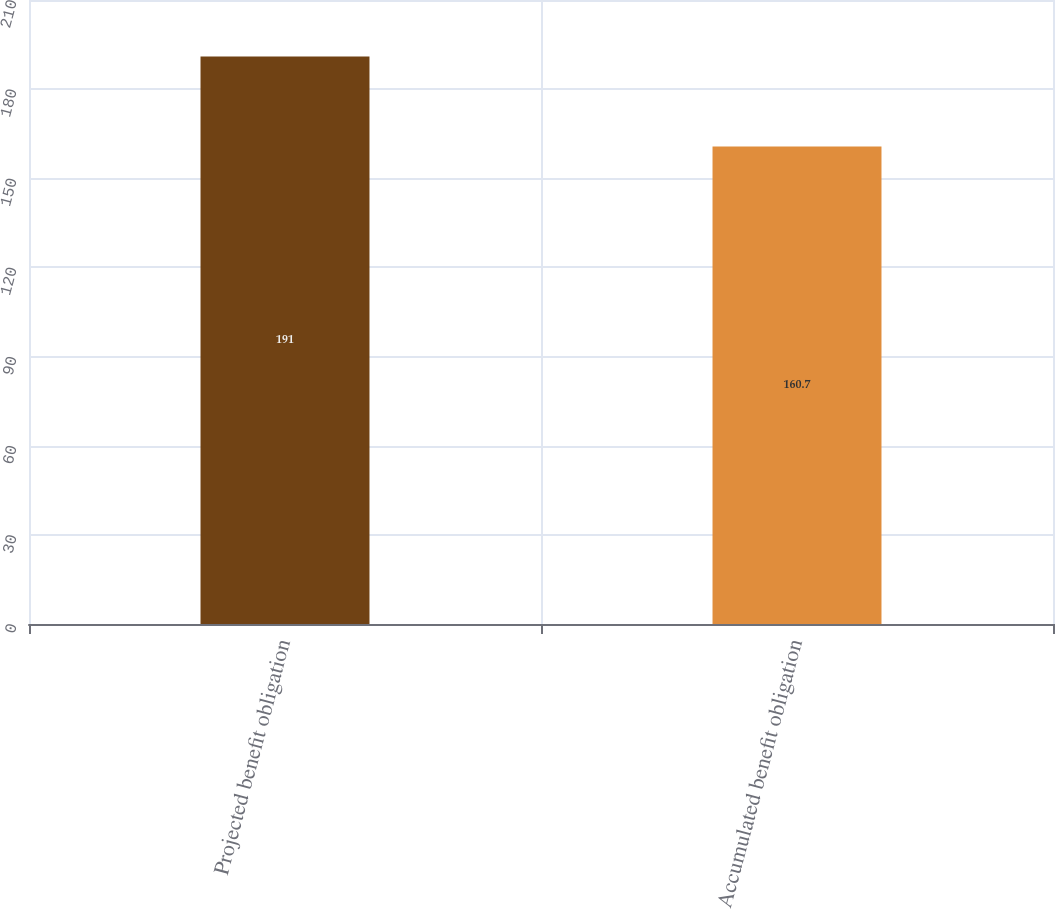Convert chart to OTSL. <chart><loc_0><loc_0><loc_500><loc_500><bar_chart><fcel>Projected benefit obligation<fcel>Accumulated benefit obligation<nl><fcel>191<fcel>160.7<nl></chart> 